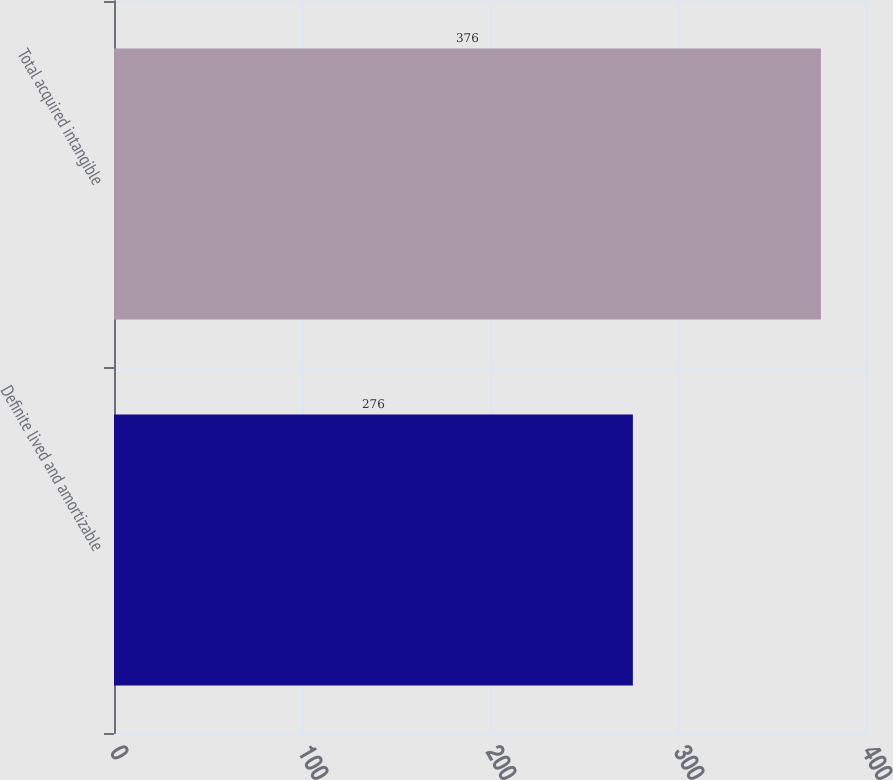<chart> <loc_0><loc_0><loc_500><loc_500><bar_chart><fcel>Definite lived and amortizable<fcel>Total acquired intangible<nl><fcel>276<fcel>376<nl></chart> 